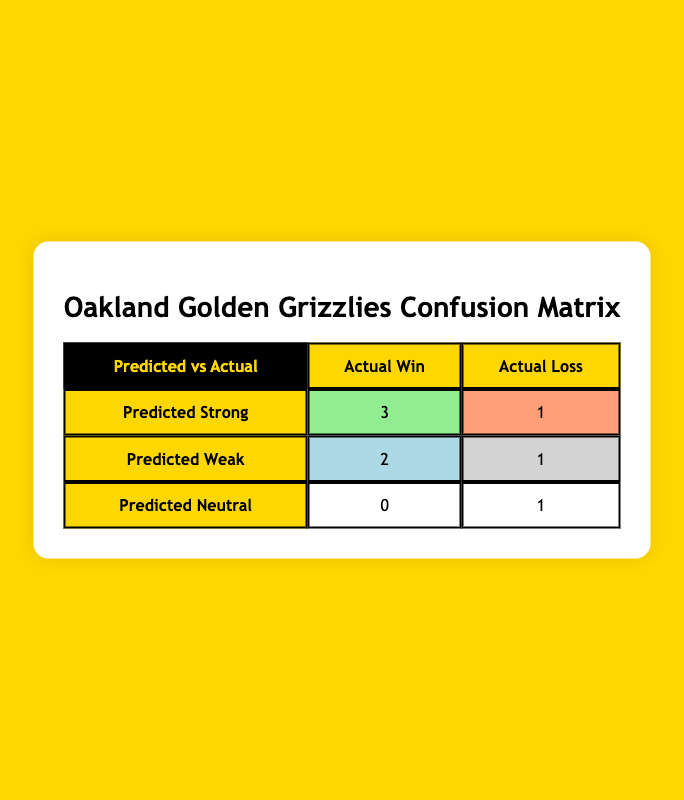What is the number of predicted strong matchups that resulted in a win? According to the table, there are 3 strong matchups that resulted in a win. They are the games against Detroit Mercy Titans, Cleveland State Vikings, and IUPUI Jaguars, which are all categorized under Predicted Strong and Actual Win.
Answer: 3 How many matchups were predicted to be weak and actually resulted in a loss? The table shows 2 weak matchups that resulted in a loss, specifically against Wright State Raiders and Youngstown State Penguins, both noted under Predicted Weak and Actual Loss.
Answer: 2 What is the total count of actual wins in all matchups? To find the total actual wins, we add the wins in predicted strong matchups (3) and weak matchups (1), and strong neutral matchups (0). Thus, total wins = 3 (strong) + 1 (weak) + 0 (neutral) = 4.
Answer: 4 Did the Oakland Golden Grizzlies predict a strong matchup against Northern Kentucky Norse? The table indicates that Northern Kentucky Norse had a Predicted matchup of neutral, therefore they did not predict it as a strong matchup.
Answer: No Which predicted matchup type had the highest actual win count? The predicted strong matchup category had the highest actual win count, resulting in 3 wins when reviewing the corresponding data. The weak category had only 1.
Answer: Predicted strong matchups How many total predicted matchups were categorized as neutral? The table indicates that there was 1 matchup categorized as neutral, which is the game against Northern Kentucky Norse under Predicted Neutral.
Answer: 1 What is the difference in the number of true positives and false positives? The number of true positives (actual wins for predicted strong matchups) is 3, and false positives (actual losses for predicted strong matchups) is 1. The difference is calculated as 3 - 1 = 2.
Answer: 2 Is it true that all predicted weak matchups resulted in at least one win? Reviewing the table, it's observed that out of the 3 predicted weak matchups (against Wright State Raiders, Green Bay Phoenix, and Purdue Fort Wayne Mastodons), only the matchup against Purdue Fort Wayne Mastodons resulted in a win. So, it is not true that all weak matchups won.
Answer: No What are the actual outcomes for the matchups predicted as weak? The actual outcomes for the weak matchups include a loss against Wright State Raiders and wins against Green Bay Phoenix and Purdue Fort Wayne Mastodons.
Answer: Loss, Win, Win 